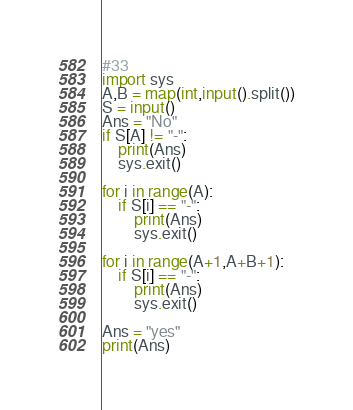Convert code to text. <code><loc_0><loc_0><loc_500><loc_500><_Python_>#33
import sys
A,B = map(int,input().split())
S = input()
Ans = "No"
if S[A] != "-":
    print(Ans)
    sys.exit()
    
for i in range(A):
    if S[i] == "-":
        print(Ans)
        sys.exit()

for i in range(A+1,A+B+1):
    if S[i] == "-":
        print(Ans)
        sys.exit()

Ans = "yes"
print(Ans)

</code> 